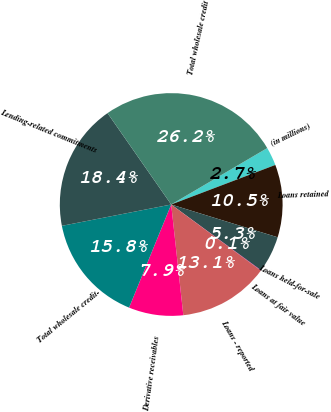<chart> <loc_0><loc_0><loc_500><loc_500><pie_chart><fcel>(in millions)<fcel>Loans retained<fcel>Loans held-for-sale<fcel>Loans at fair value<fcel>Loans - reported<fcel>Derivative receivables<fcel>Total wholesale credit-<fcel>Lending-related commitments<fcel>Total wholesale credit<nl><fcel>2.68%<fcel>10.53%<fcel>5.3%<fcel>0.06%<fcel>13.15%<fcel>7.91%<fcel>15.76%<fcel>18.38%<fcel>26.23%<nl></chart> 